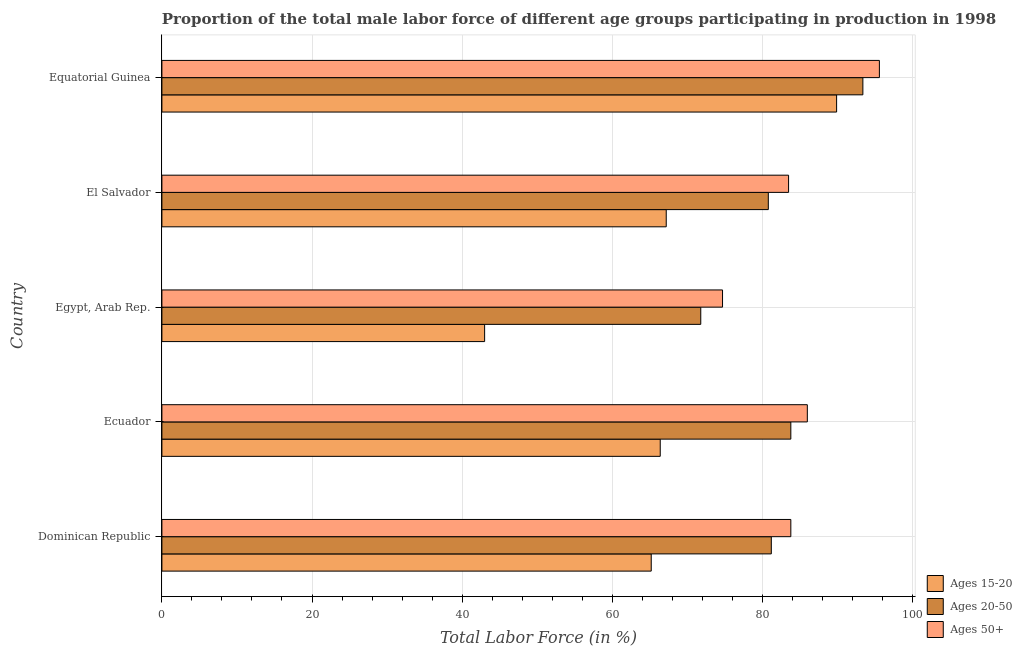How many different coloured bars are there?
Provide a short and direct response. 3. Are the number of bars on each tick of the Y-axis equal?
Your response must be concise. Yes. What is the label of the 2nd group of bars from the top?
Provide a succinct answer. El Salvador. What is the percentage of male labor force within the age group 20-50 in Dominican Republic?
Ensure brevity in your answer.  81.2. Across all countries, what is the maximum percentage of male labor force above age 50?
Keep it short and to the point. 95.6. In which country was the percentage of male labor force above age 50 maximum?
Provide a succinct answer. Equatorial Guinea. In which country was the percentage of male labor force within the age group 15-20 minimum?
Your answer should be very brief. Egypt, Arab Rep. What is the total percentage of male labor force within the age group 15-20 in the graph?
Keep it short and to the point. 331.7. What is the difference between the percentage of male labor force within the age group 15-20 in Ecuador and that in Equatorial Guinea?
Your answer should be very brief. -23.5. What is the difference between the percentage of male labor force within the age group 15-20 in Equatorial Guinea and the percentage of male labor force within the age group 20-50 in Egypt, Arab Rep.?
Your answer should be very brief. 18.1. What is the average percentage of male labor force within the age group 15-20 per country?
Your answer should be compact. 66.34. What is the difference between the percentage of male labor force within the age group 15-20 and percentage of male labor force within the age group 20-50 in Ecuador?
Offer a very short reply. -17.4. In how many countries, is the percentage of male labor force within the age group 15-20 greater than 28 %?
Your response must be concise. 5. Is the percentage of male labor force above age 50 in Ecuador less than that in El Salvador?
Offer a terse response. No. Is the difference between the percentage of male labor force within the age group 20-50 in El Salvador and Equatorial Guinea greater than the difference between the percentage of male labor force within the age group 15-20 in El Salvador and Equatorial Guinea?
Offer a very short reply. Yes. What is the difference between the highest and the second highest percentage of male labor force within the age group 15-20?
Provide a short and direct response. 22.7. What is the difference between the highest and the lowest percentage of male labor force above age 50?
Your answer should be very brief. 20.9. In how many countries, is the percentage of male labor force above age 50 greater than the average percentage of male labor force above age 50 taken over all countries?
Keep it short and to the point. 2. What does the 1st bar from the top in Equatorial Guinea represents?
Offer a terse response. Ages 50+. What does the 3rd bar from the bottom in Egypt, Arab Rep. represents?
Your answer should be very brief. Ages 50+. Is it the case that in every country, the sum of the percentage of male labor force within the age group 15-20 and percentage of male labor force within the age group 20-50 is greater than the percentage of male labor force above age 50?
Your answer should be compact. Yes. How many bars are there?
Your answer should be compact. 15. How many countries are there in the graph?
Ensure brevity in your answer.  5. What is the difference between two consecutive major ticks on the X-axis?
Offer a terse response. 20. Are the values on the major ticks of X-axis written in scientific E-notation?
Offer a terse response. No. Where does the legend appear in the graph?
Provide a short and direct response. Bottom right. How many legend labels are there?
Ensure brevity in your answer.  3. What is the title of the graph?
Keep it short and to the point. Proportion of the total male labor force of different age groups participating in production in 1998. What is the label or title of the Y-axis?
Your answer should be very brief. Country. What is the Total Labor Force (in %) in Ages 15-20 in Dominican Republic?
Your answer should be very brief. 65.2. What is the Total Labor Force (in %) in Ages 20-50 in Dominican Republic?
Provide a succinct answer. 81.2. What is the Total Labor Force (in %) in Ages 50+ in Dominican Republic?
Offer a very short reply. 83.8. What is the Total Labor Force (in %) in Ages 15-20 in Ecuador?
Offer a very short reply. 66.4. What is the Total Labor Force (in %) of Ages 20-50 in Ecuador?
Make the answer very short. 83.8. What is the Total Labor Force (in %) in Ages 50+ in Ecuador?
Your response must be concise. 86. What is the Total Labor Force (in %) of Ages 20-50 in Egypt, Arab Rep.?
Offer a very short reply. 71.8. What is the Total Labor Force (in %) in Ages 50+ in Egypt, Arab Rep.?
Give a very brief answer. 74.7. What is the Total Labor Force (in %) of Ages 15-20 in El Salvador?
Give a very brief answer. 67.2. What is the Total Labor Force (in %) of Ages 20-50 in El Salvador?
Offer a terse response. 80.8. What is the Total Labor Force (in %) of Ages 50+ in El Salvador?
Provide a succinct answer. 83.5. What is the Total Labor Force (in %) of Ages 15-20 in Equatorial Guinea?
Your response must be concise. 89.9. What is the Total Labor Force (in %) in Ages 20-50 in Equatorial Guinea?
Keep it short and to the point. 93.4. What is the Total Labor Force (in %) in Ages 50+ in Equatorial Guinea?
Offer a terse response. 95.6. Across all countries, what is the maximum Total Labor Force (in %) in Ages 15-20?
Ensure brevity in your answer.  89.9. Across all countries, what is the maximum Total Labor Force (in %) in Ages 20-50?
Make the answer very short. 93.4. Across all countries, what is the maximum Total Labor Force (in %) of Ages 50+?
Offer a very short reply. 95.6. Across all countries, what is the minimum Total Labor Force (in %) in Ages 15-20?
Give a very brief answer. 43. Across all countries, what is the minimum Total Labor Force (in %) of Ages 20-50?
Ensure brevity in your answer.  71.8. Across all countries, what is the minimum Total Labor Force (in %) in Ages 50+?
Your answer should be compact. 74.7. What is the total Total Labor Force (in %) in Ages 15-20 in the graph?
Ensure brevity in your answer.  331.7. What is the total Total Labor Force (in %) in Ages 20-50 in the graph?
Provide a succinct answer. 411. What is the total Total Labor Force (in %) of Ages 50+ in the graph?
Make the answer very short. 423.6. What is the difference between the Total Labor Force (in %) in Ages 15-20 in Dominican Republic and that in Ecuador?
Offer a very short reply. -1.2. What is the difference between the Total Labor Force (in %) in Ages 20-50 in Dominican Republic and that in Ecuador?
Ensure brevity in your answer.  -2.6. What is the difference between the Total Labor Force (in %) in Ages 15-20 in Dominican Republic and that in Egypt, Arab Rep.?
Offer a terse response. 22.2. What is the difference between the Total Labor Force (in %) of Ages 50+ in Dominican Republic and that in Egypt, Arab Rep.?
Ensure brevity in your answer.  9.1. What is the difference between the Total Labor Force (in %) of Ages 15-20 in Dominican Republic and that in El Salvador?
Offer a terse response. -2. What is the difference between the Total Labor Force (in %) of Ages 50+ in Dominican Republic and that in El Salvador?
Offer a terse response. 0.3. What is the difference between the Total Labor Force (in %) in Ages 15-20 in Dominican Republic and that in Equatorial Guinea?
Your response must be concise. -24.7. What is the difference between the Total Labor Force (in %) of Ages 20-50 in Dominican Republic and that in Equatorial Guinea?
Offer a terse response. -12.2. What is the difference between the Total Labor Force (in %) of Ages 50+ in Dominican Republic and that in Equatorial Guinea?
Your response must be concise. -11.8. What is the difference between the Total Labor Force (in %) in Ages 15-20 in Ecuador and that in Egypt, Arab Rep.?
Your response must be concise. 23.4. What is the difference between the Total Labor Force (in %) in Ages 15-20 in Ecuador and that in El Salvador?
Give a very brief answer. -0.8. What is the difference between the Total Labor Force (in %) in Ages 15-20 in Ecuador and that in Equatorial Guinea?
Provide a succinct answer. -23.5. What is the difference between the Total Labor Force (in %) in Ages 15-20 in Egypt, Arab Rep. and that in El Salvador?
Provide a succinct answer. -24.2. What is the difference between the Total Labor Force (in %) of Ages 20-50 in Egypt, Arab Rep. and that in El Salvador?
Offer a very short reply. -9. What is the difference between the Total Labor Force (in %) of Ages 50+ in Egypt, Arab Rep. and that in El Salvador?
Offer a very short reply. -8.8. What is the difference between the Total Labor Force (in %) in Ages 15-20 in Egypt, Arab Rep. and that in Equatorial Guinea?
Provide a short and direct response. -46.9. What is the difference between the Total Labor Force (in %) of Ages 20-50 in Egypt, Arab Rep. and that in Equatorial Guinea?
Give a very brief answer. -21.6. What is the difference between the Total Labor Force (in %) in Ages 50+ in Egypt, Arab Rep. and that in Equatorial Guinea?
Your answer should be compact. -20.9. What is the difference between the Total Labor Force (in %) in Ages 15-20 in El Salvador and that in Equatorial Guinea?
Offer a very short reply. -22.7. What is the difference between the Total Labor Force (in %) in Ages 50+ in El Salvador and that in Equatorial Guinea?
Your answer should be compact. -12.1. What is the difference between the Total Labor Force (in %) of Ages 15-20 in Dominican Republic and the Total Labor Force (in %) of Ages 20-50 in Ecuador?
Offer a very short reply. -18.6. What is the difference between the Total Labor Force (in %) of Ages 15-20 in Dominican Republic and the Total Labor Force (in %) of Ages 50+ in Ecuador?
Your answer should be compact. -20.8. What is the difference between the Total Labor Force (in %) in Ages 20-50 in Dominican Republic and the Total Labor Force (in %) in Ages 50+ in Egypt, Arab Rep.?
Offer a very short reply. 6.5. What is the difference between the Total Labor Force (in %) in Ages 15-20 in Dominican Republic and the Total Labor Force (in %) in Ages 20-50 in El Salvador?
Offer a very short reply. -15.6. What is the difference between the Total Labor Force (in %) of Ages 15-20 in Dominican Republic and the Total Labor Force (in %) of Ages 50+ in El Salvador?
Your answer should be very brief. -18.3. What is the difference between the Total Labor Force (in %) of Ages 20-50 in Dominican Republic and the Total Labor Force (in %) of Ages 50+ in El Salvador?
Your response must be concise. -2.3. What is the difference between the Total Labor Force (in %) of Ages 15-20 in Dominican Republic and the Total Labor Force (in %) of Ages 20-50 in Equatorial Guinea?
Your response must be concise. -28.2. What is the difference between the Total Labor Force (in %) in Ages 15-20 in Dominican Republic and the Total Labor Force (in %) in Ages 50+ in Equatorial Guinea?
Make the answer very short. -30.4. What is the difference between the Total Labor Force (in %) in Ages 20-50 in Dominican Republic and the Total Labor Force (in %) in Ages 50+ in Equatorial Guinea?
Make the answer very short. -14.4. What is the difference between the Total Labor Force (in %) of Ages 15-20 in Ecuador and the Total Labor Force (in %) of Ages 20-50 in Egypt, Arab Rep.?
Your response must be concise. -5.4. What is the difference between the Total Labor Force (in %) of Ages 15-20 in Ecuador and the Total Labor Force (in %) of Ages 50+ in Egypt, Arab Rep.?
Your response must be concise. -8.3. What is the difference between the Total Labor Force (in %) in Ages 20-50 in Ecuador and the Total Labor Force (in %) in Ages 50+ in Egypt, Arab Rep.?
Ensure brevity in your answer.  9.1. What is the difference between the Total Labor Force (in %) in Ages 15-20 in Ecuador and the Total Labor Force (in %) in Ages 20-50 in El Salvador?
Your answer should be compact. -14.4. What is the difference between the Total Labor Force (in %) in Ages 15-20 in Ecuador and the Total Labor Force (in %) in Ages 50+ in El Salvador?
Your answer should be very brief. -17.1. What is the difference between the Total Labor Force (in %) of Ages 15-20 in Ecuador and the Total Labor Force (in %) of Ages 50+ in Equatorial Guinea?
Ensure brevity in your answer.  -29.2. What is the difference between the Total Labor Force (in %) in Ages 20-50 in Ecuador and the Total Labor Force (in %) in Ages 50+ in Equatorial Guinea?
Ensure brevity in your answer.  -11.8. What is the difference between the Total Labor Force (in %) in Ages 15-20 in Egypt, Arab Rep. and the Total Labor Force (in %) in Ages 20-50 in El Salvador?
Give a very brief answer. -37.8. What is the difference between the Total Labor Force (in %) of Ages 15-20 in Egypt, Arab Rep. and the Total Labor Force (in %) of Ages 50+ in El Salvador?
Your response must be concise. -40.5. What is the difference between the Total Labor Force (in %) of Ages 20-50 in Egypt, Arab Rep. and the Total Labor Force (in %) of Ages 50+ in El Salvador?
Give a very brief answer. -11.7. What is the difference between the Total Labor Force (in %) of Ages 15-20 in Egypt, Arab Rep. and the Total Labor Force (in %) of Ages 20-50 in Equatorial Guinea?
Keep it short and to the point. -50.4. What is the difference between the Total Labor Force (in %) of Ages 15-20 in Egypt, Arab Rep. and the Total Labor Force (in %) of Ages 50+ in Equatorial Guinea?
Ensure brevity in your answer.  -52.6. What is the difference between the Total Labor Force (in %) in Ages 20-50 in Egypt, Arab Rep. and the Total Labor Force (in %) in Ages 50+ in Equatorial Guinea?
Keep it short and to the point. -23.8. What is the difference between the Total Labor Force (in %) of Ages 15-20 in El Salvador and the Total Labor Force (in %) of Ages 20-50 in Equatorial Guinea?
Your answer should be very brief. -26.2. What is the difference between the Total Labor Force (in %) of Ages 15-20 in El Salvador and the Total Labor Force (in %) of Ages 50+ in Equatorial Guinea?
Your response must be concise. -28.4. What is the difference between the Total Labor Force (in %) in Ages 20-50 in El Salvador and the Total Labor Force (in %) in Ages 50+ in Equatorial Guinea?
Ensure brevity in your answer.  -14.8. What is the average Total Labor Force (in %) of Ages 15-20 per country?
Ensure brevity in your answer.  66.34. What is the average Total Labor Force (in %) of Ages 20-50 per country?
Ensure brevity in your answer.  82.2. What is the average Total Labor Force (in %) of Ages 50+ per country?
Your answer should be compact. 84.72. What is the difference between the Total Labor Force (in %) of Ages 15-20 and Total Labor Force (in %) of Ages 50+ in Dominican Republic?
Provide a short and direct response. -18.6. What is the difference between the Total Labor Force (in %) of Ages 20-50 and Total Labor Force (in %) of Ages 50+ in Dominican Republic?
Make the answer very short. -2.6. What is the difference between the Total Labor Force (in %) in Ages 15-20 and Total Labor Force (in %) in Ages 20-50 in Ecuador?
Ensure brevity in your answer.  -17.4. What is the difference between the Total Labor Force (in %) in Ages 15-20 and Total Labor Force (in %) in Ages 50+ in Ecuador?
Your answer should be very brief. -19.6. What is the difference between the Total Labor Force (in %) of Ages 20-50 and Total Labor Force (in %) of Ages 50+ in Ecuador?
Your answer should be compact. -2.2. What is the difference between the Total Labor Force (in %) of Ages 15-20 and Total Labor Force (in %) of Ages 20-50 in Egypt, Arab Rep.?
Your response must be concise. -28.8. What is the difference between the Total Labor Force (in %) in Ages 15-20 and Total Labor Force (in %) in Ages 50+ in Egypt, Arab Rep.?
Your response must be concise. -31.7. What is the difference between the Total Labor Force (in %) in Ages 20-50 and Total Labor Force (in %) in Ages 50+ in Egypt, Arab Rep.?
Provide a short and direct response. -2.9. What is the difference between the Total Labor Force (in %) in Ages 15-20 and Total Labor Force (in %) in Ages 50+ in El Salvador?
Give a very brief answer. -16.3. What is the difference between the Total Labor Force (in %) in Ages 15-20 and Total Labor Force (in %) in Ages 20-50 in Equatorial Guinea?
Provide a short and direct response. -3.5. What is the difference between the Total Labor Force (in %) in Ages 15-20 and Total Labor Force (in %) in Ages 50+ in Equatorial Guinea?
Provide a short and direct response. -5.7. What is the ratio of the Total Labor Force (in %) of Ages 15-20 in Dominican Republic to that in Ecuador?
Your response must be concise. 0.98. What is the ratio of the Total Labor Force (in %) of Ages 50+ in Dominican Republic to that in Ecuador?
Provide a succinct answer. 0.97. What is the ratio of the Total Labor Force (in %) of Ages 15-20 in Dominican Republic to that in Egypt, Arab Rep.?
Offer a very short reply. 1.52. What is the ratio of the Total Labor Force (in %) in Ages 20-50 in Dominican Republic to that in Egypt, Arab Rep.?
Provide a succinct answer. 1.13. What is the ratio of the Total Labor Force (in %) of Ages 50+ in Dominican Republic to that in Egypt, Arab Rep.?
Your answer should be very brief. 1.12. What is the ratio of the Total Labor Force (in %) of Ages 15-20 in Dominican Republic to that in El Salvador?
Keep it short and to the point. 0.97. What is the ratio of the Total Labor Force (in %) in Ages 20-50 in Dominican Republic to that in El Salvador?
Give a very brief answer. 1. What is the ratio of the Total Labor Force (in %) of Ages 50+ in Dominican Republic to that in El Salvador?
Offer a very short reply. 1. What is the ratio of the Total Labor Force (in %) in Ages 15-20 in Dominican Republic to that in Equatorial Guinea?
Offer a very short reply. 0.73. What is the ratio of the Total Labor Force (in %) of Ages 20-50 in Dominican Republic to that in Equatorial Guinea?
Provide a succinct answer. 0.87. What is the ratio of the Total Labor Force (in %) in Ages 50+ in Dominican Republic to that in Equatorial Guinea?
Give a very brief answer. 0.88. What is the ratio of the Total Labor Force (in %) in Ages 15-20 in Ecuador to that in Egypt, Arab Rep.?
Offer a terse response. 1.54. What is the ratio of the Total Labor Force (in %) in Ages 20-50 in Ecuador to that in Egypt, Arab Rep.?
Provide a succinct answer. 1.17. What is the ratio of the Total Labor Force (in %) of Ages 50+ in Ecuador to that in Egypt, Arab Rep.?
Offer a very short reply. 1.15. What is the ratio of the Total Labor Force (in %) in Ages 20-50 in Ecuador to that in El Salvador?
Provide a succinct answer. 1.04. What is the ratio of the Total Labor Force (in %) in Ages 50+ in Ecuador to that in El Salvador?
Your response must be concise. 1.03. What is the ratio of the Total Labor Force (in %) in Ages 15-20 in Ecuador to that in Equatorial Guinea?
Give a very brief answer. 0.74. What is the ratio of the Total Labor Force (in %) of Ages 20-50 in Ecuador to that in Equatorial Guinea?
Your answer should be compact. 0.9. What is the ratio of the Total Labor Force (in %) in Ages 50+ in Ecuador to that in Equatorial Guinea?
Ensure brevity in your answer.  0.9. What is the ratio of the Total Labor Force (in %) in Ages 15-20 in Egypt, Arab Rep. to that in El Salvador?
Give a very brief answer. 0.64. What is the ratio of the Total Labor Force (in %) in Ages 20-50 in Egypt, Arab Rep. to that in El Salvador?
Your response must be concise. 0.89. What is the ratio of the Total Labor Force (in %) of Ages 50+ in Egypt, Arab Rep. to that in El Salvador?
Make the answer very short. 0.89. What is the ratio of the Total Labor Force (in %) in Ages 15-20 in Egypt, Arab Rep. to that in Equatorial Guinea?
Your answer should be compact. 0.48. What is the ratio of the Total Labor Force (in %) in Ages 20-50 in Egypt, Arab Rep. to that in Equatorial Guinea?
Provide a succinct answer. 0.77. What is the ratio of the Total Labor Force (in %) in Ages 50+ in Egypt, Arab Rep. to that in Equatorial Guinea?
Offer a terse response. 0.78. What is the ratio of the Total Labor Force (in %) in Ages 15-20 in El Salvador to that in Equatorial Guinea?
Provide a succinct answer. 0.75. What is the ratio of the Total Labor Force (in %) of Ages 20-50 in El Salvador to that in Equatorial Guinea?
Ensure brevity in your answer.  0.87. What is the ratio of the Total Labor Force (in %) in Ages 50+ in El Salvador to that in Equatorial Guinea?
Keep it short and to the point. 0.87. What is the difference between the highest and the second highest Total Labor Force (in %) of Ages 15-20?
Your answer should be compact. 22.7. What is the difference between the highest and the second highest Total Labor Force (in %) in Ages 20-50?
Provide a short and direct response. 9.6. What is the difference between the highest and the lowest Total Labor Force (in %) of Ages 15-20?
Your response must be concise. 46.9. What is the difference between the highest and the lowest Total Labor Force (in %) in Ages 20-50?
Ensure brevity in your answer.  21.6. What is the difference between the highest and the lowest Total Labor Force (in %) of Ages 50+?
Make the answer very short. 20.9. 